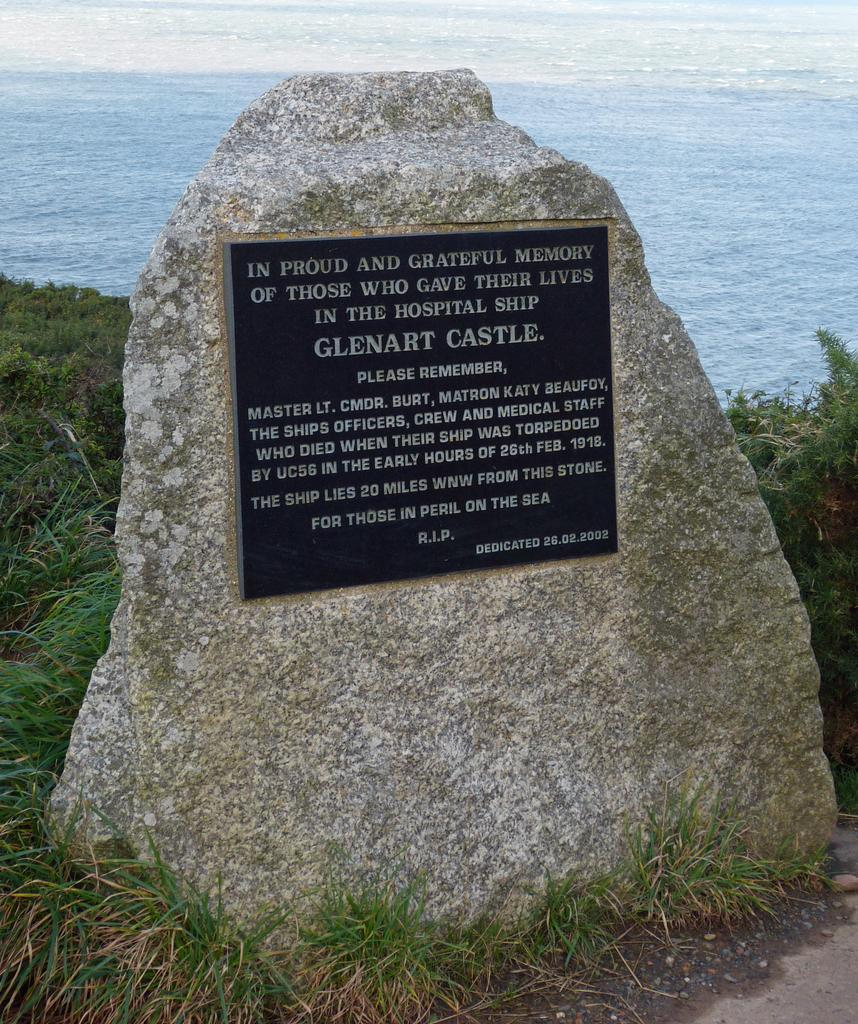What is the main object in the image? There is a memorial stone in the image. How is the memorial stone attached to the rock? The memorial stone is attached to a rock. What type of vegetation can be seen in the image? There is grass in the image. What natural feature is visible in the background of the image? There is a body of water (possibly the sea) in the image, and water is flowing in it. What type of paint is used on the stamp in the image? There is no paint or stamp present in the image. How does the memorial stone affect the temper of the person in the image? There is no person present in the image, and the memorial stone's effect on someone's temper cannot be determined from the image. 